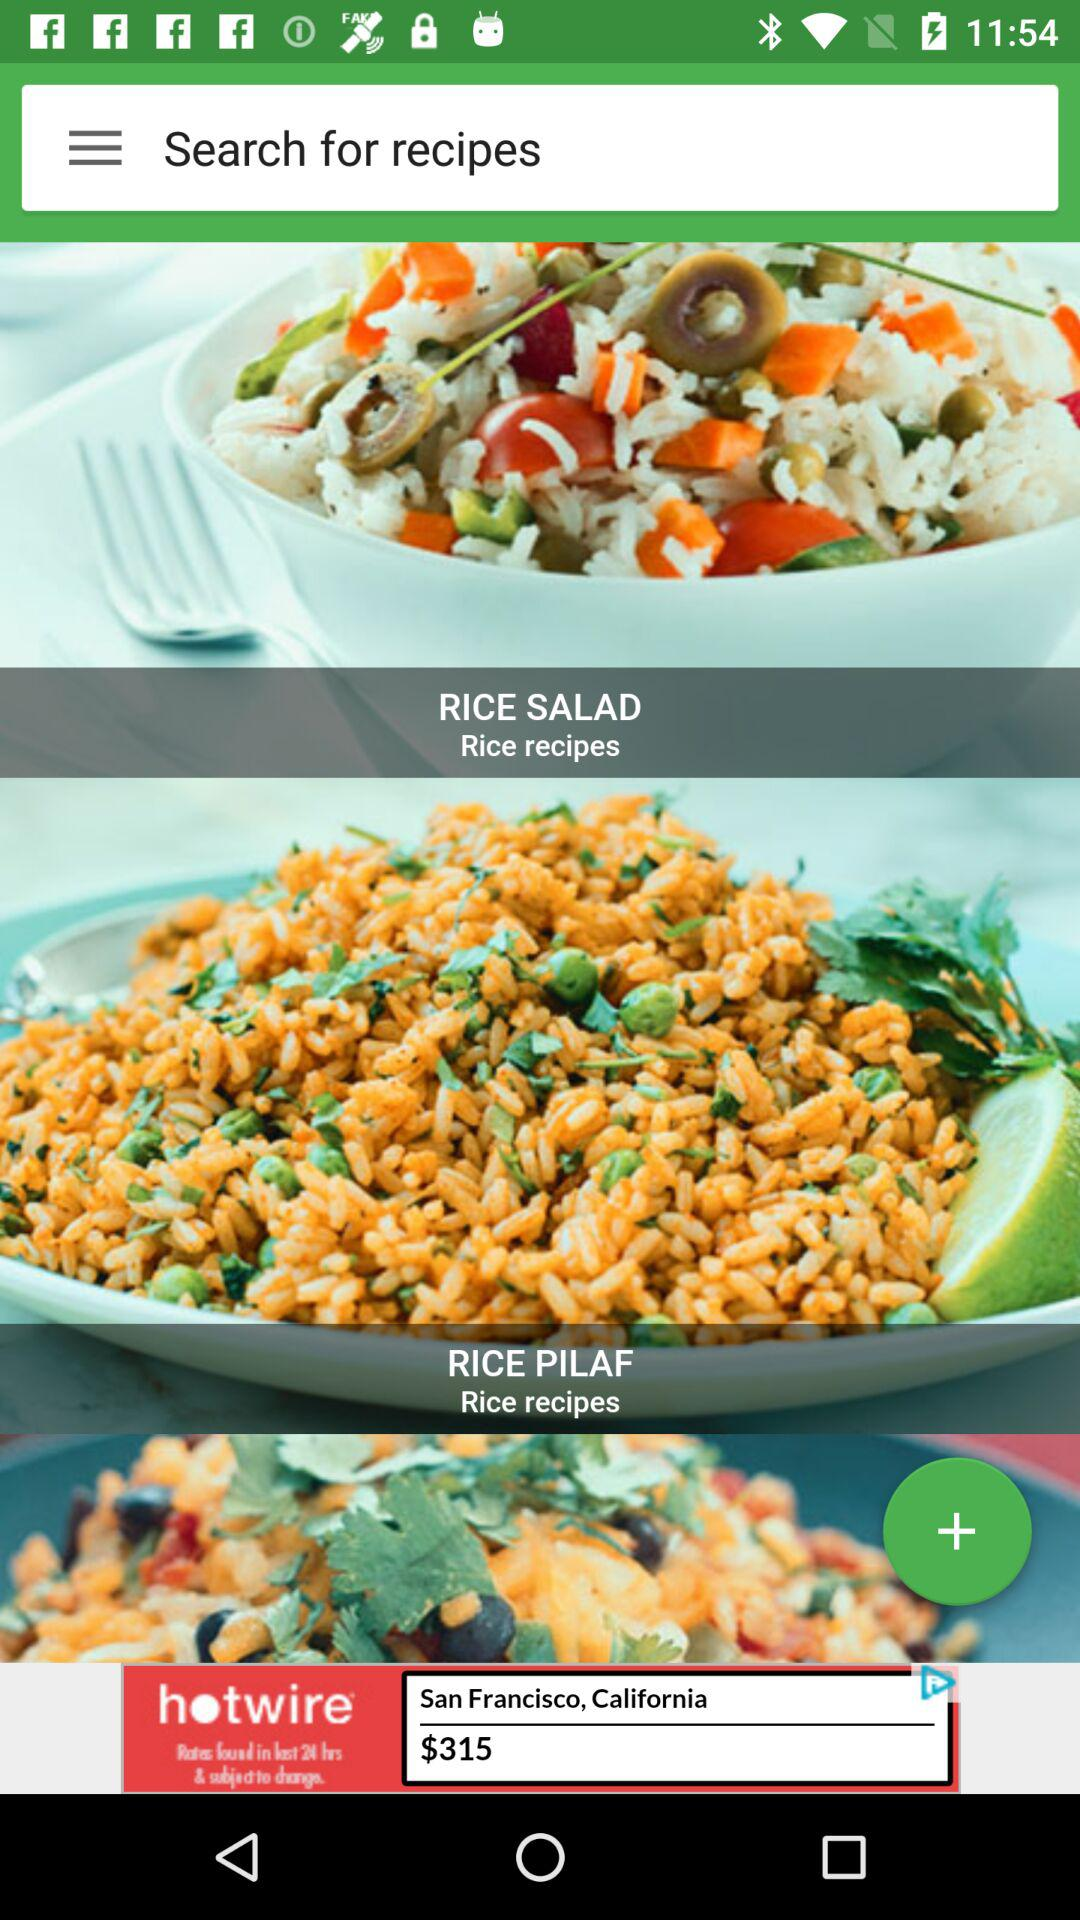How many recipes are there in total?
Answer the question using a single word or phrase. 3 